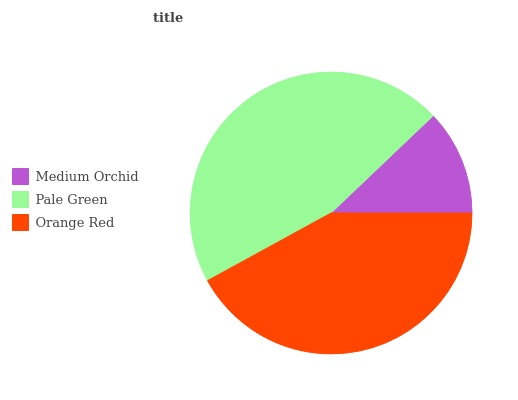Is Medium Orchid the minimum?
Answer yes or no. Yes. Is Pale Green the maximum?
Answer yes or no. Yes. Is Orange Red the minimum?
Answer yes or no. No. Is Orange Red the maximum?
Answer yes or no. No. Is Pale Green greater than Orange Red?
Answer yes or no. Yes. Is Orange Red less than Pale Green?
Answer yes or no. Yes. Is Orange Red greater than Pale Green?
Answer yes or no. No. Is Pale Green less than Orange Red?
Answer yes or no. No. Is Orange Red the high median?
Answer yes or no. Yes. Is Orange Red the low median?
Answer yes or no. Yes. Is Pale Green the high median?
Answer yes or no. No. Is Medium Orchid the low median?
Answer yes or no. No. 